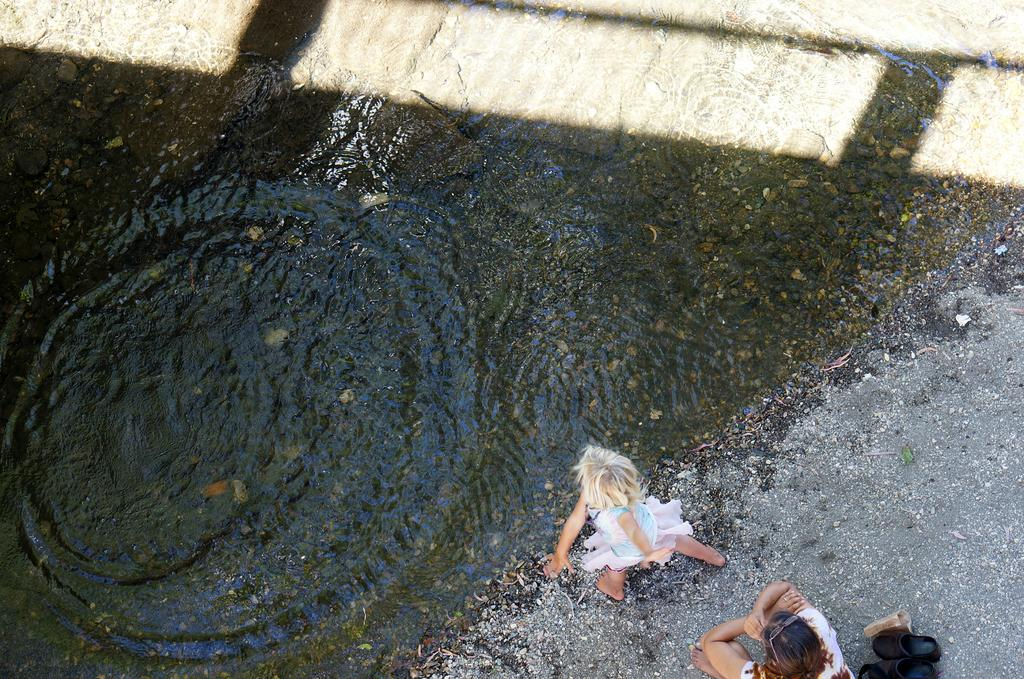How many people are in the image? There are two persons in the image. What is the surface they are standing on? The persons are on the sand. What is located behind the persons? There is a pair of footwear behind the persons. What is in front of the persons? There is water in front of the persons. What type of card is being used by the persons in the image? There is no card present in the image. How many pets are visible in the image? There are no pets visible in the image. 